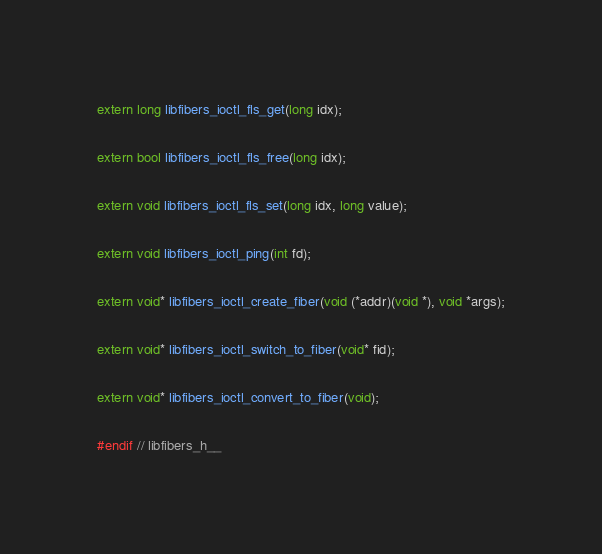Convert code to text. <code><loc_0><loc_0><loc_500><loc_500><_C_>extern long libfibers_ioctl_fls_get(long idx);

extern bool libfibers_ioctl_fls_free(long idx);

extern void libfibers_ioctl_fls_set(long idx, long value);

extern void libfibers_ioctl_ping(int fd);

extern void* libfibers_ioctl_create_fiber(void (*addr)(void *), void *args);

extern void* libfibers_ioctl_switch_to_fiber(void* fid);

extern void* libfibers_ioctl_convert_to_fiber(void);

#endif // libfibers_h__
</code> 